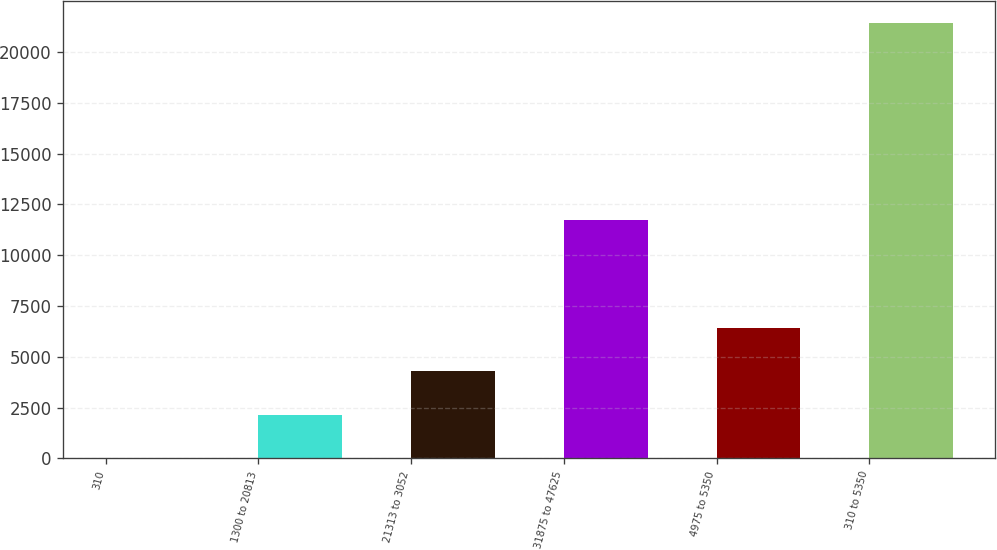<chart> <loc_0><loc_0><loc_500><loc_500><bar_chart><fcel>310<fcel>1300 to 20813<fcel>21313 to 3052<fcel>31875 to 47625<fcel>4975 to 5350<fcel>310 to 5350<nl><fcel>4.1<fcel>2145.9<fcel>4287.7<fcel>11742.6<fcel>6429.5<fcel>21422.1<nl></chart> 